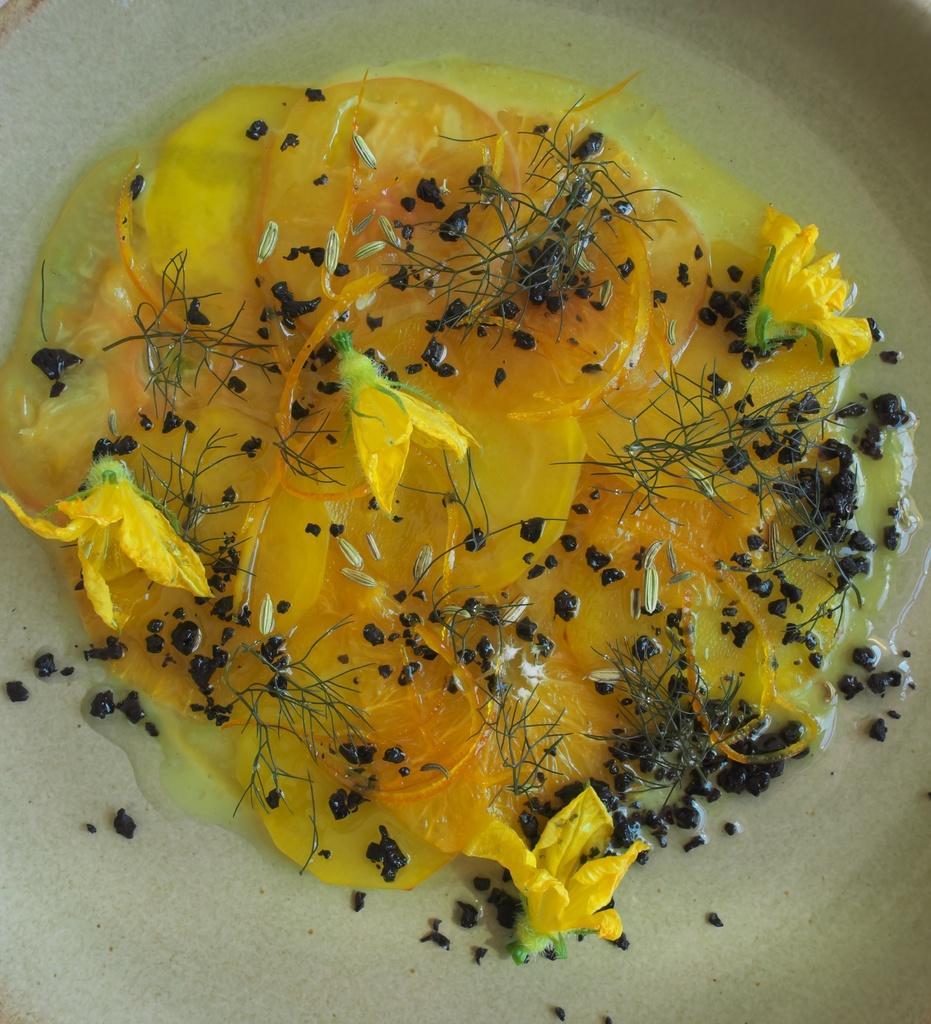Could you give a brief overview of what you see in this image? In this image there is one plate, and in the plate there is some food. 